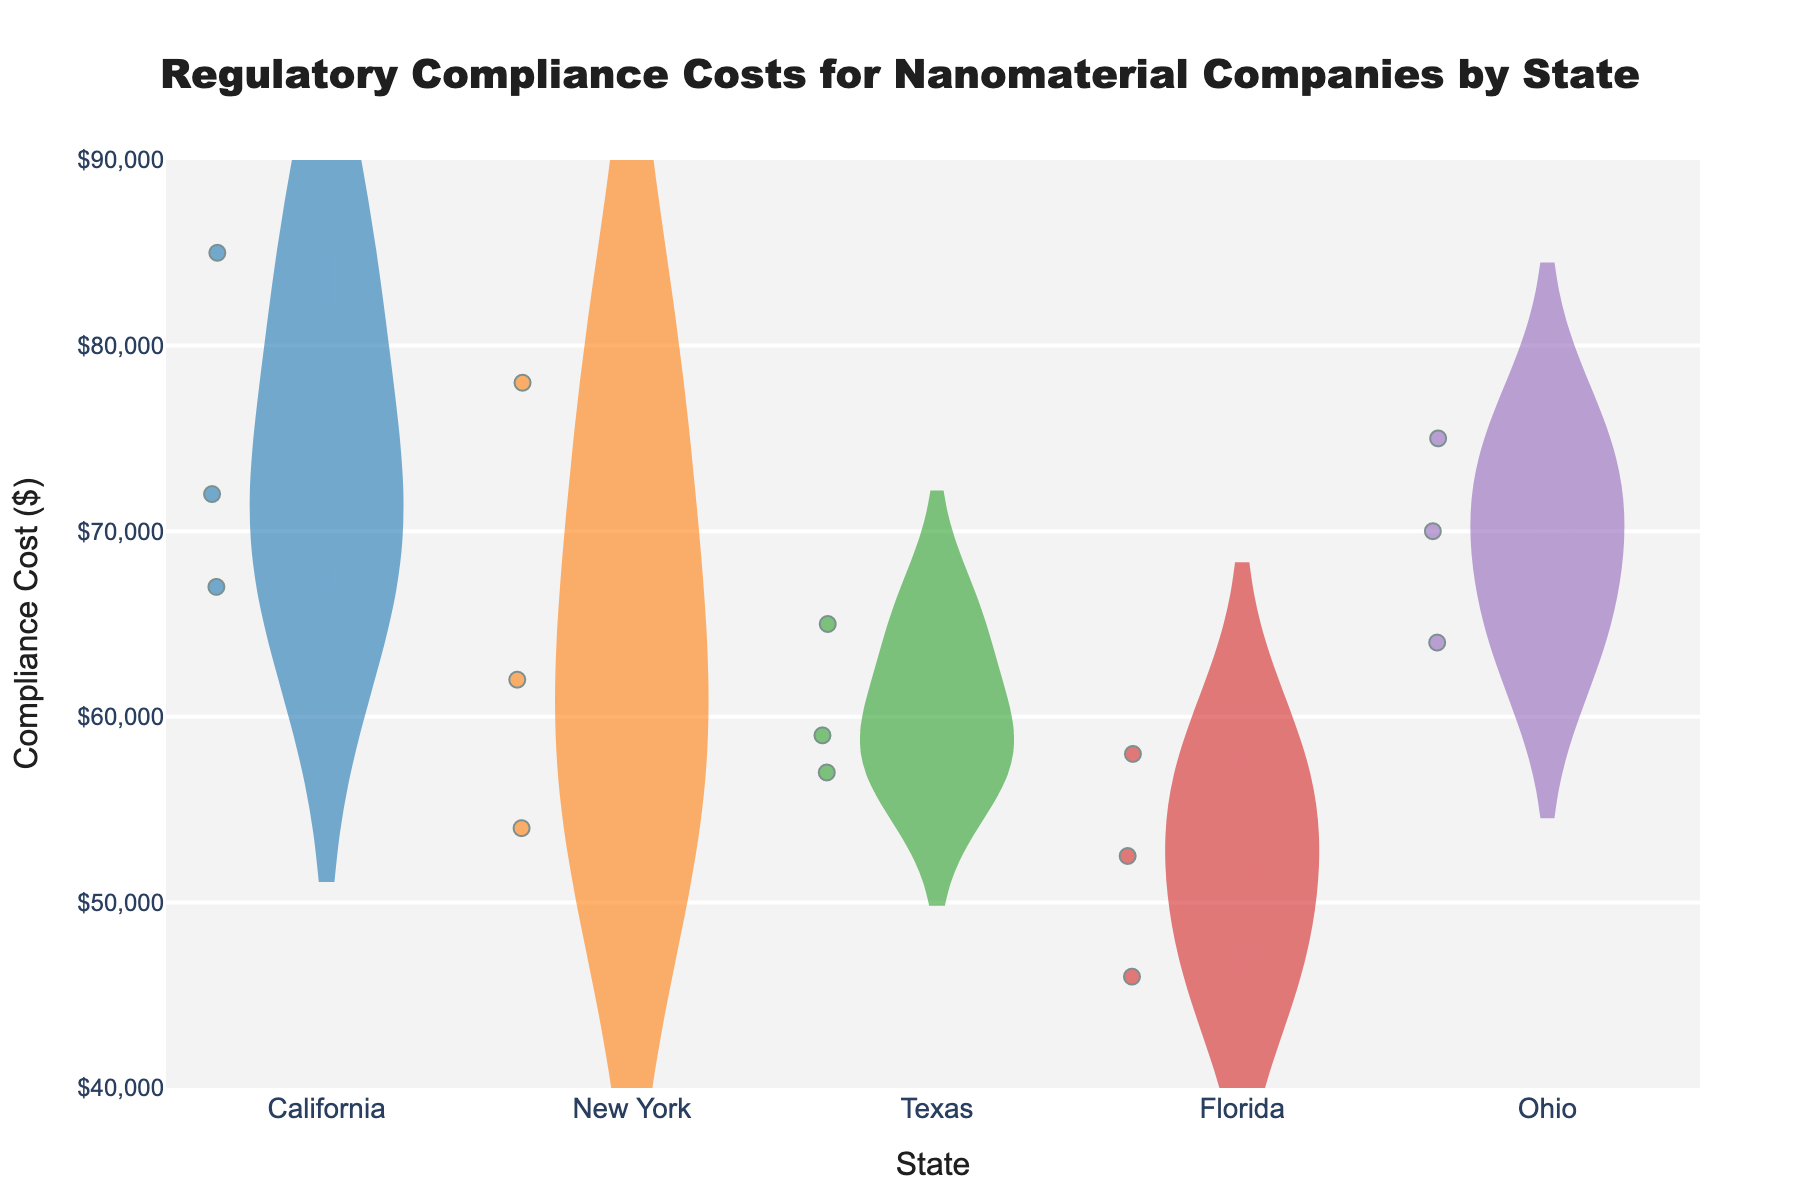What is the range of compliance costs for companies in California? Look at the leftmost violin plot labeled California. The range of the plot spans from the minimum to the maximum cost values.
Answer: $67,000 to $85,000 Which state has the lowest minimum compliance cost? Identify the lowest point across all the violin plots. Florida has the lowest value at $46,000.
Answer: Florida How many data points are shown for Texas? Count the individual dots in the Texas violin plot. There are three visible dots, indicating three data points.
Answer: 3 What is the median compliance cost for companies in New York? The median value is marked by a horizontal line inside the New York violin plot. The median value appears to be around $62,000.
Answer: $62,000 Which state has the highest average compliance cost? Compare the central tendency (mean lines) of all state violin plots. California has the highest average compliance cost.
Answer: California Do companies in Ohio show a higher variation in compliance costs compared to those in Texas? Variation is indicated by the spread of the violin plots. The Ohio plot is more spread out compared to Texas.
Answer: Yes Which state shows the least variation in compliance costs? Identify the state with the most compact (least spread out) violin plot. The plot for Florida is the most compact.
Answer: Florida What is the difference in the highest compliance cost between California and New York? Look at the topmost points of the violin plots for California and New York. California's highest is $85,000, New York's highest is $78,000, so the difference is $7,000.
Answer: $7,000 Is there any state where the compliance costs for all companies fall below $60,000? Check each state’s violin plot to see if the top of the plot is below $60,000. Florida is the only state with all values below $60,000.
Answer: Florida How does the cost distribution of Florida compare to Ohio? Compare the shape and spread of the Florida and Ohio violin plots. Florida's values are lower and less spread out, indicating lower and more consistent costs.
Answer: Florida's costs are lower and more consistent 